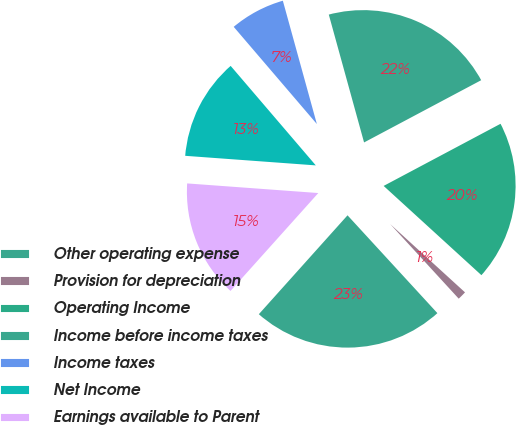Convert chart. <chart><loc_0><loc_0><loc_500><loc_500><pie_chart><fcel>Other operating expense<fcel>Provision for depreciation<fcel>Operating Income<fcel>Income before income taxes<fcel>Income taxes<fcel>Net Income<fcel>Earnings available to Parent<nl><fcel>23.46%<fcel>1.4%<fcel>19.55%<fcel>21.51%<fcel>6.98%<fcel>12.57%<fcel>14.53%<nl></chart> 